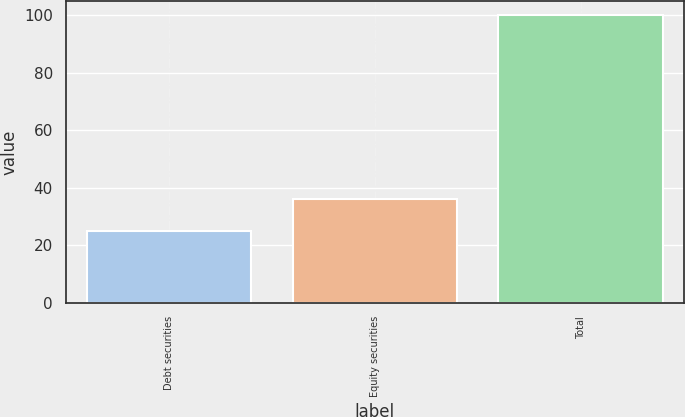<chart> <loc_0><loc_0><loc_500><loc_500><bar_chart><fcel>Debt securities<fcel>Equity securities<fcel>Total<nl><fcel>25<fcel>36<fcel>100<nl></chart> 